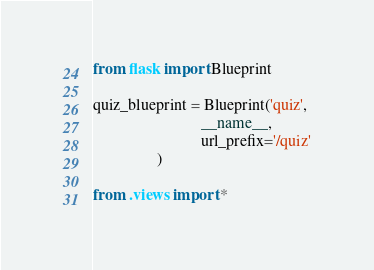<code> <loc_0><loc_0><loc_500><loc_500><_Python_>from flask import Blueprint

quiz_blueprint = Blueprint('quiz', 
                           __name__, 
                           url_prefix='/quiz'
                )

from .views import * </code> 